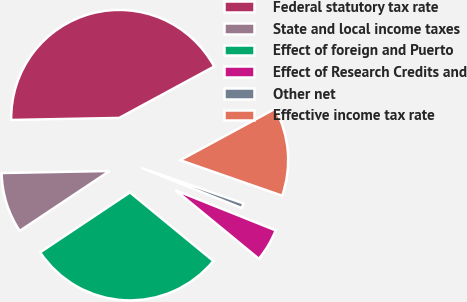Convert chart. <chart><loc_0><loc_0><loc_500><loc_500><pie_chart><fcel>Federal statutory tax rate<fcel>State and local income taxes<fcel>Effect of foreign and Puerto<fcel>Effect of Research Credits and<fcel>Other net<fcel>Effective income tax rate<nl><fcel>42.4%<fcel>9.06%<fcel>29.68%<fcel>4.89%<fcel>0.73%<fcel>13.23%<nl></chart> 